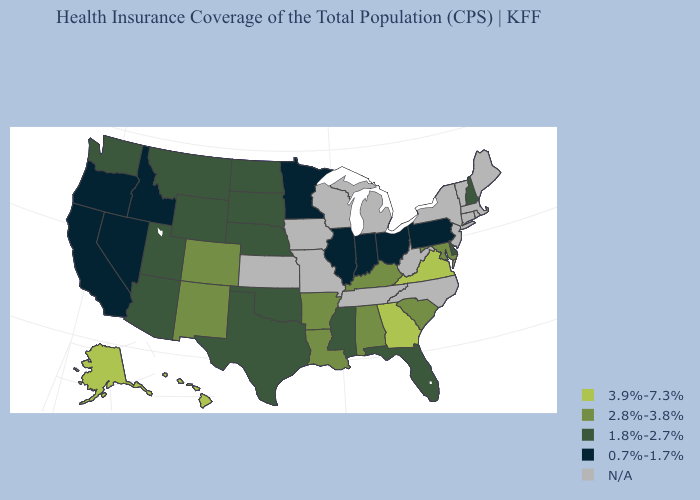What is the value of Maine?
Answer briefly. N/A. Among the states that border Oklahoma , does Arkansas have the lowest value?
Write a very short answer. No. Does the first symbol in the legend represent the smallest category?
Answer briefly. No. What is the value of Idaho?
Give a very brief answer. 0.7%-1.7%. What is the value of Texas?
Answer briefly. 1.8%-2.7%. Does Illinois have the highest value in the MidWest?
Keep it brief. No. Does Oregon have the lowest value in the USA?
Be succinct. Yes. What is the value of South Carolina?
Keep it brief. 2.8%-3.8%. Among the states that border South Dakota , does Nebraska have the highest value?
Short answer required. Yes. What is the value of Mississippi?
Answer briefly. 1.8%-2.7%. Name the states that have a value in the range 1.8%-2.7%?
Short answer required. Arizona, Delaware, Florida, Mississippi, Montana, Nebraska, New Hampshire, North Dakota, Oklahoma, South Dakota, Texas, Utah, Washington, Wyoming. What is the value of Vermont?
Answer briefly. N/A. Does the map have missing data?
Concise answer only. Yes. 